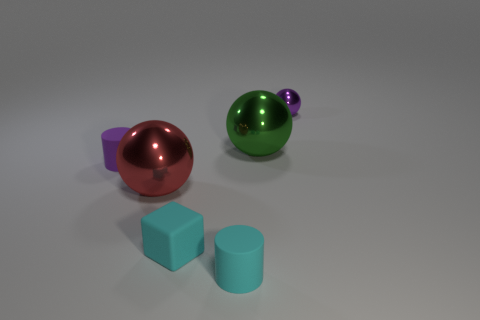Add 3 brown cylinders. How many objects exist? 9 Subtract all cubes. How many objects are left? 5 Subtract all cyan objects. Subtract all tiny shiny objects. How many objects are left? 3 Add 3 big red shiny spheres. How many big red shiny spheres are left? 4 Add 6 purple metal spheres. How many purple metal spheres exist? 7 Subtract 0 green cubes. How many objects are left? 6 